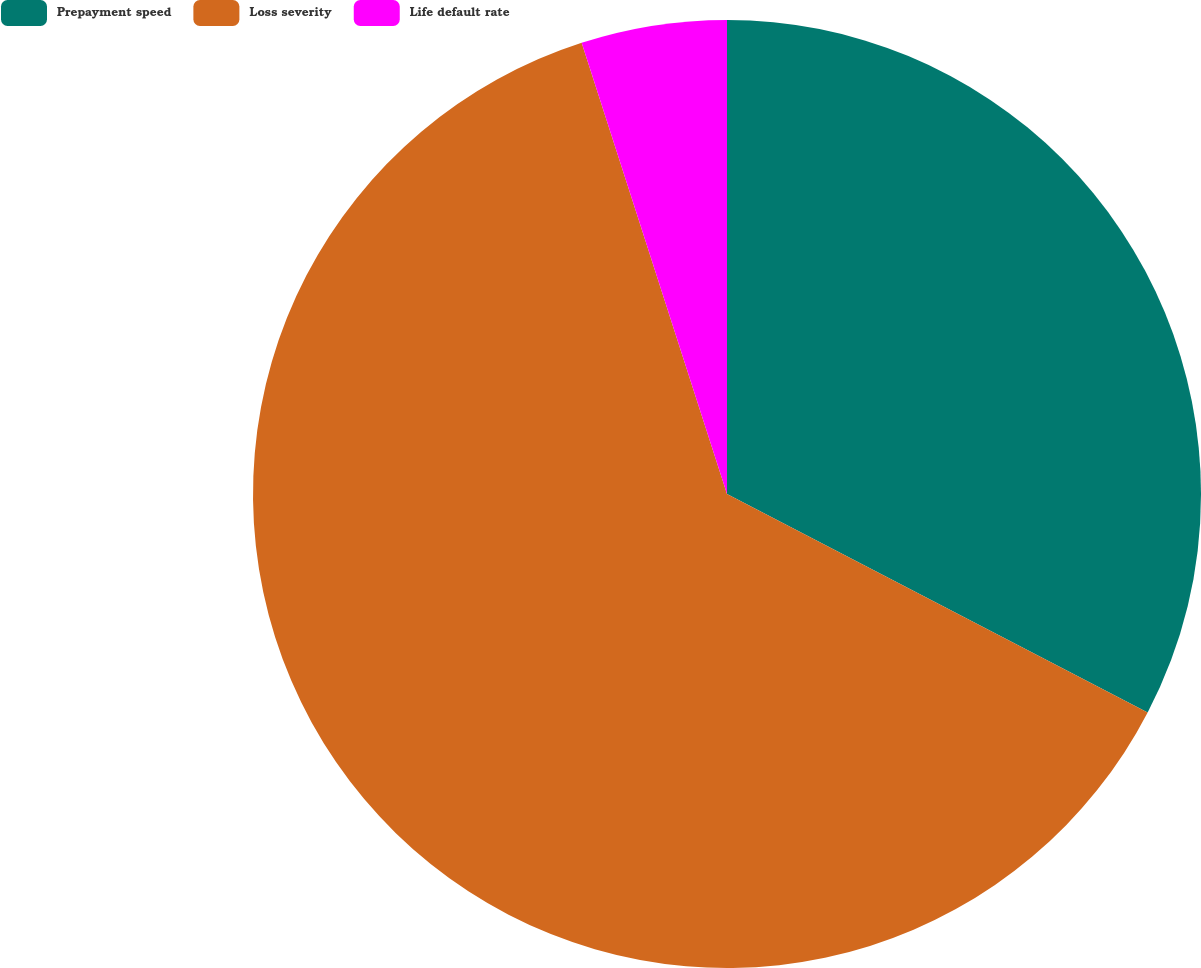Convert chart. <chart><loc_0><loc_0><loc_500><loc_500><pie_chart><fcel>Prepayment speed<fcel>Loss severity<fcel>Life default rate<nl><fcel>32.62%<fcel>62.41%<fcel>4.96%<nl></chart> 